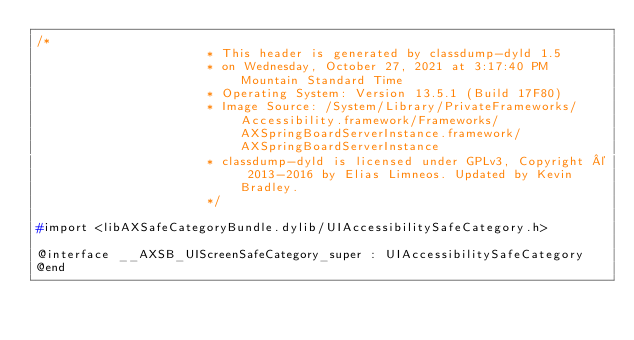<code> <loc_0><loc_0><loc_500><loc_500><_C_>/*
                       * This header is generated by classdump-dyld 1.5
                       * on Wednesday, October 27, 2021 at 3:17:40 PM Mountain Standard Time
                       * Operating System: Version 13.5.1 (Build 17F80)
                       * Image Source: /System/Library/PrivateFrameworks/Accessibility.framework/Frameworks/AXSpringBoardServerInstance.framework/AXSpringBoardServerInstance
                       * classdump-dyld is licensed under GPLv3, Copyright © 2013-2016 by Elias Limneos. Updated by Kevin Bradley.
                       */

#import <libAXSafeCategoryBundle.dylib/UIAccessibilitySafeCategory.h>

@interface __AXSB_UIScreenSafeCategory_super : UIAccessibilitySafeCategory
@end

</code> 